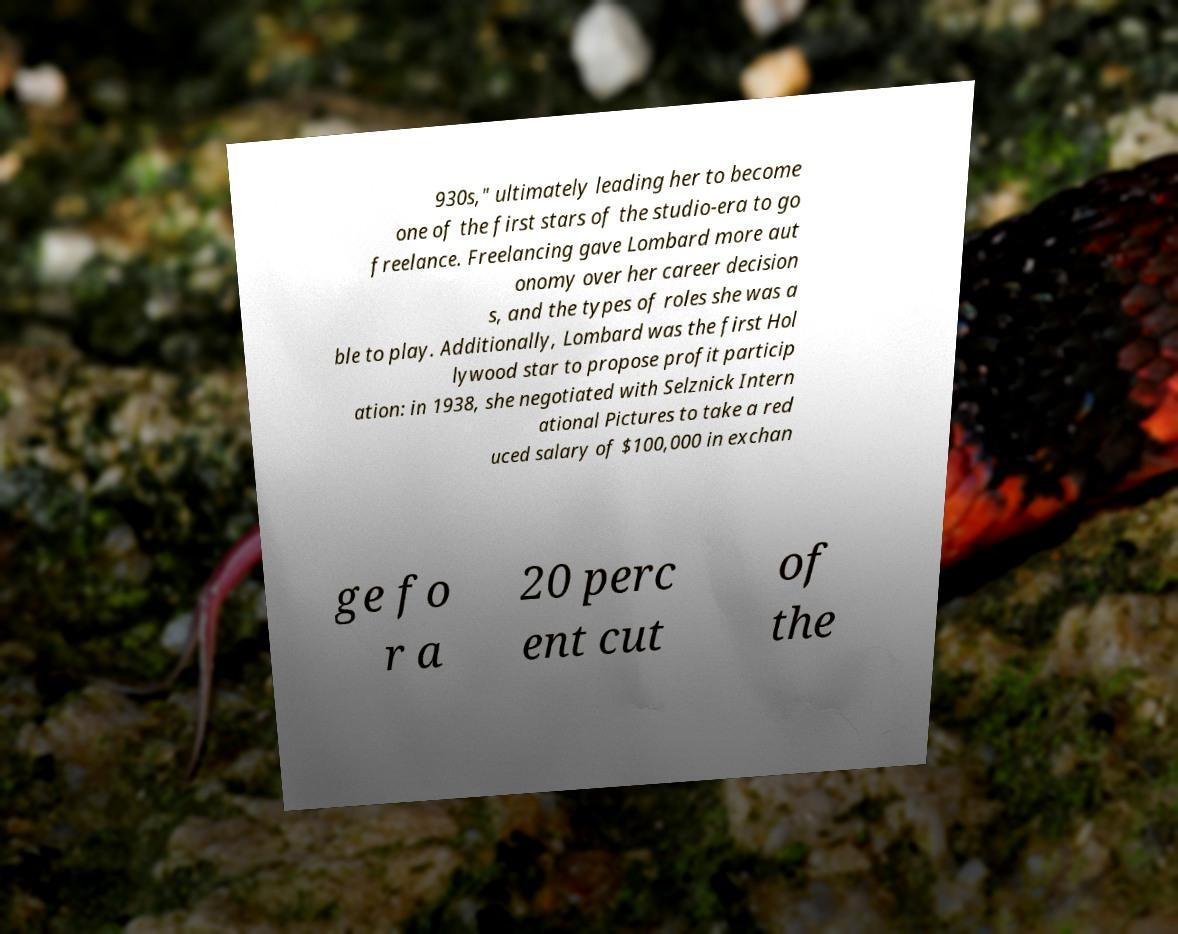Can you read and provide the text displayed in the image?This photo seems to have some interesting text. Can you extract and type it out for me? 930s," ultimately leading her to become one of the first stars of the studio-era to go freelance. Freelancing gave Lombard more aut onomy over her career decision s, and the types of roles she was a ble to play. Additionally, Lombard was the first Hol lywood star to propose profit particip ation: in 1938, she negotiated with Selznick Intern ational Pictures to take a red uced salary of $100,000 in exchan ge fo r a 20 perc ent cut of the 